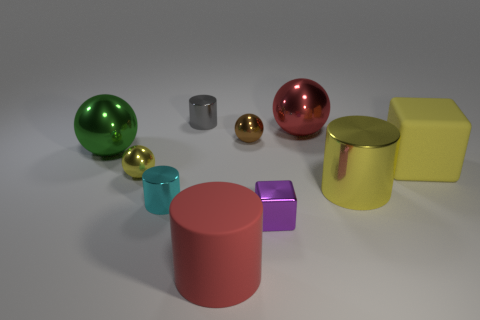Subtract 1 cylinders. How many cylinders are left? 3 Subtract all cylinders. How many objects are left? 6 Subtract all metallic blocks. Subtract all small cyan metallic things. How many objects are left? 8 Add 3 tiny purple shiny cubes. How many tiny purple shiny cubes are left? 4 Add 5 big matte cylinders. How many big matte cylinders exist? 6 Subtract 0 gray cubes. How many objects are left? 10 